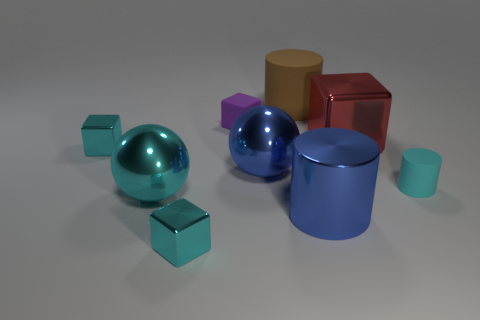Subtract all red blocks. How many blocks are left? 3 Subtract all small purple blocks. How many blocks are left? 3 Subtract all brown blocks. Subtract all gray cylinders. How many blocks are left? 4 Add 1 large spheres. How many objects exist? 10 Subtract all balls. How many objects are left? 7 Subtract all small cyan rubber cylinders. Subtract all yellow rubber things. How many objects are left? 8 Add 7 large shiny balls. How many large shiny balls are left? 9 Add 1 big blue things. How many big blue things exist? 3 Subtract 1 cyan blocks. How many objects are left? 8 